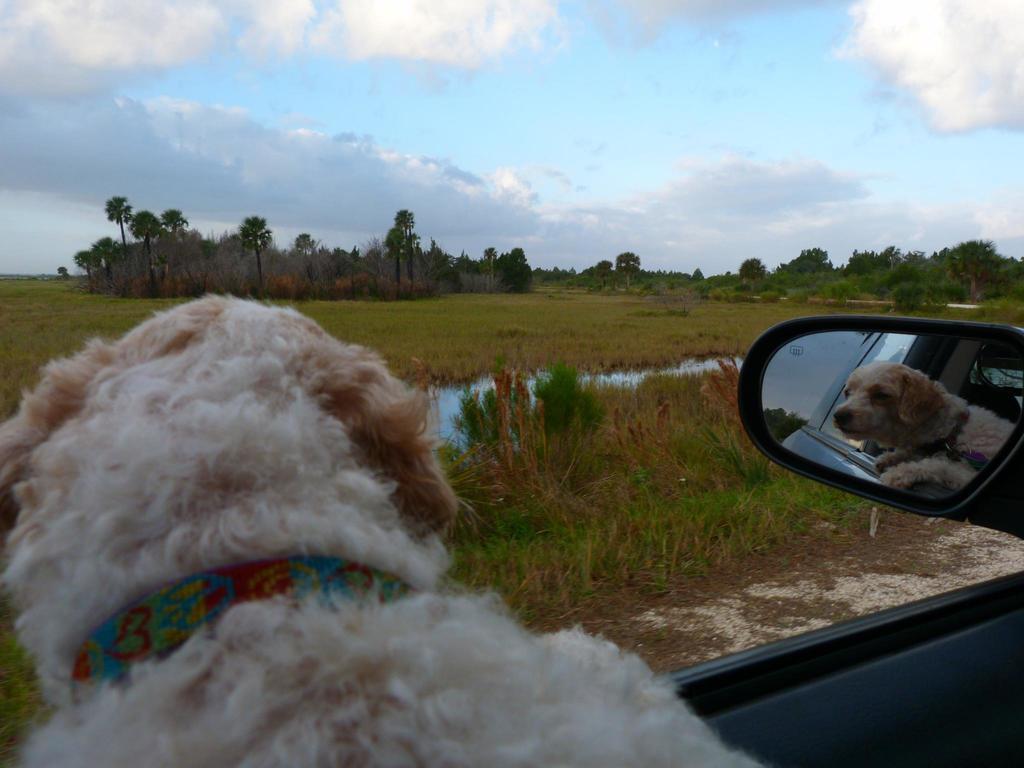Could you give a brief overview of what you see in this image? In this image we can see one dog with belt in the car, some fields, some trees, bushes, plants and grass on the surface. There are some objects on the surface, water body and at the top there is the cloudy sky. 